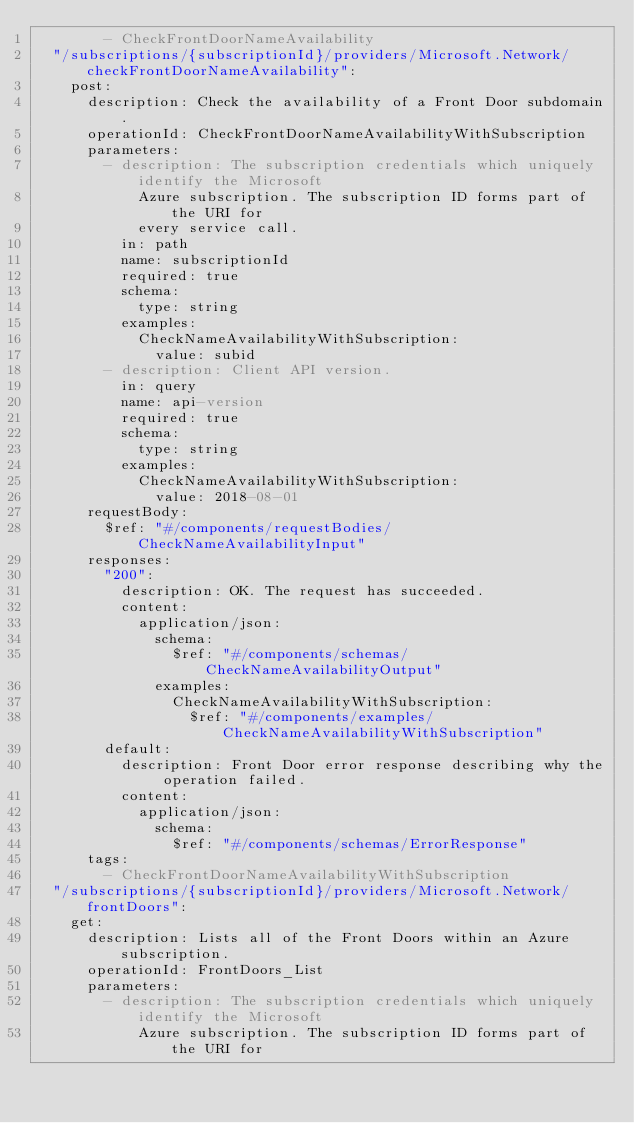<code> <loc_0><loc_0><loc_500><loc_500><_YAML_>        - CheckFrontDoorNameAvailability
  "/subscriptions/{subscriptionId}/providers/Microsoft.Network/checkFrontDoorNameAvailability":
    post:
      description: Check the availability of a Front Door subdomain.
      operationId: CheckFrontDoorNameAvailabilityWithSubscription
      parameters:
        - description: The subscription credentials which uniquely identify the Microsoft
            Azure subscription. The subscription ID forms part of the URI for
            every service call.
          in: path
          name: subscriptionId
          required: true
          schema:
            type: string
          examples:
            CheckNameAvailabilityWithSubscription:
              value: subid
        - description: Client API version.
          in: query
          name: api-version
          required: true
          schema:
            type: string
          examples:
            CheckNameAvailabilityWithSubscription:
              value: 2018-08-01
      requestBody:
        $ref: "#/components/requestBodies/CheckNameAvailabilityInput"
      responses:
        "200":
          description: OK. The request has succeeded.
          content:
            application/json:
              schema:
                $ref: "#/components/schemas/CheckNameAvailabilityOutput"
              examples:
                CheckNameAvailabilityWithSubscription:
                  $ref: "#/components/examples/CheckNameAvailabilityWithSubscription"
        default:
          description: Front Door error response describing why the operation failed.
          content:
            application/json:
              schema:
                $ref: "#/components/schemas/ErrorResponse"
      tags:
        - CheckFrontDoorNameAvailabilityWithSubscription
  "/subscriptions/{subscriptionId}/providers/Microsoft.Network/frontDoors":
    get:
      description: Lists all of the Front Doors within an Azure subscription.
      operationId: FrontDoors_List
      parameters:
        - description: The subscription credentials which uniquely identify the Microsoft
            Azure subscription. The subscription ID forms part of the URI for</code> 